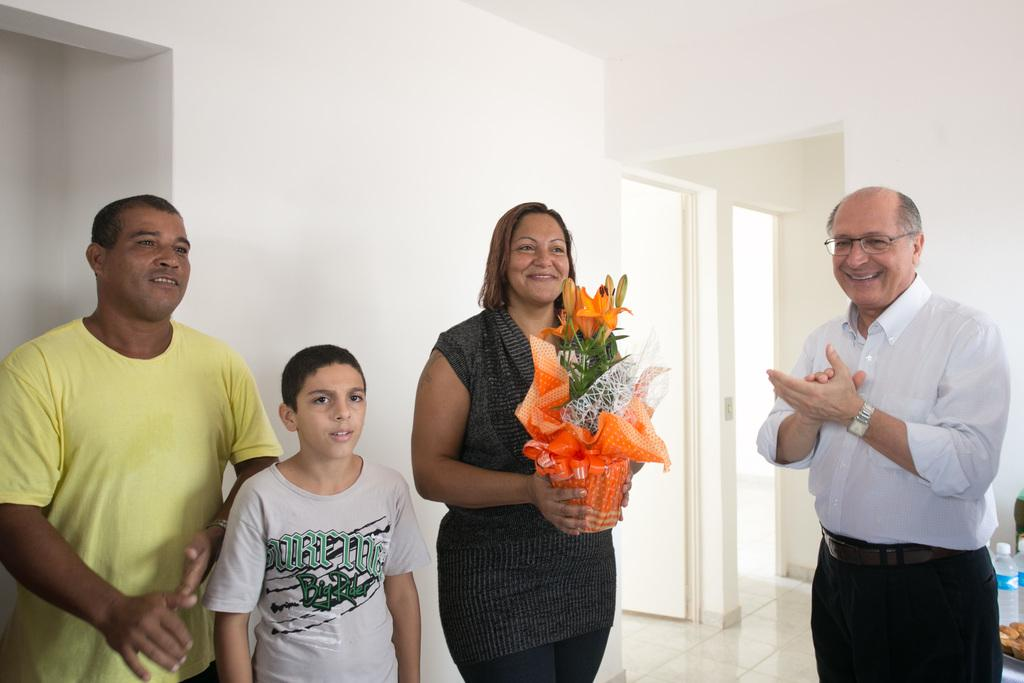How many people are present in the image? There are four persons in the image. What is the woman holding in her hands? The woman is holding a bouquet with her hands. What can be seen in the background of the image? There are walls, a door, bottles, and other objects in the background of the image. What type of muscle can be seen flexing in the image? There is no muscle flexing visible in the image. What kind of juice is being served in the image? There is no juice being served in the image. 